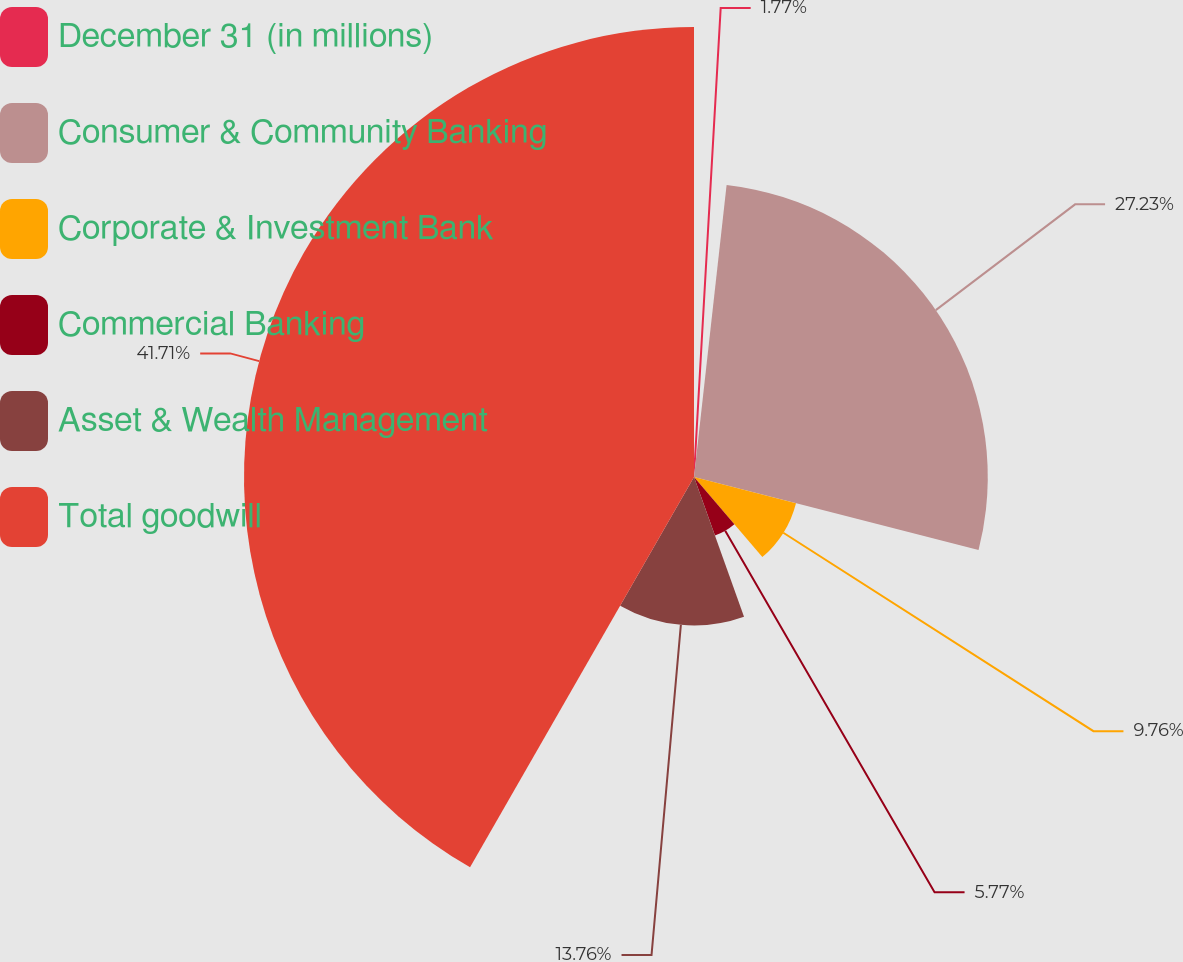<chart> <loc_0><loc_0><loc_500><loc_500><pie_chart><fcel>December 31 (in millions)<fcel>Consumer & Community Banking<fcel>Corporate & Investment Bank<fcel>Commercial Banking<fcel>Asset & Wealth Management<fcel>Total goodwill<nl><fcel>1.77%<fcel>27.23%<fcel>9.76%<fcel>5.77%<fcel>13.76%<fcel>41.71%<nl></chart> 